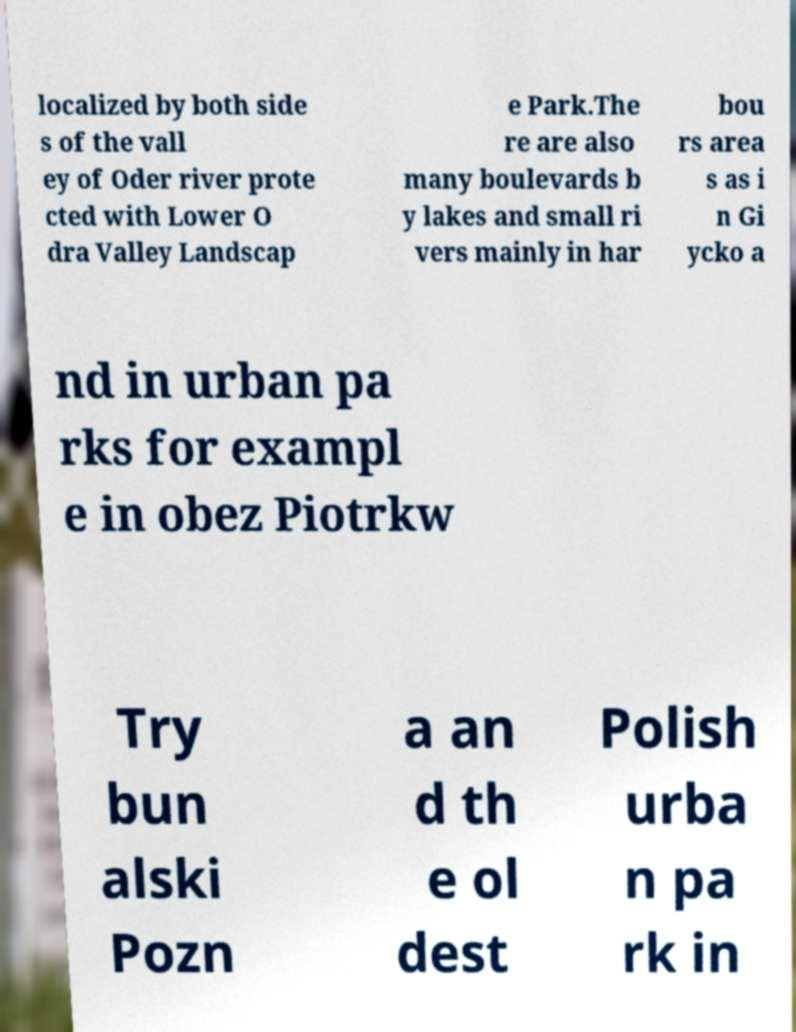What messages or text are displayed in this image? I need them in a readable, typed format. localized by both side s of the vall ey of Oder river prote cted with Lower O dra Valley Landscap e Park.The re are also many boulevards b y lakes and small ri vers mainly in har bou rs area s as i n Gi ycko a nd in urban pa rks for exampl e in obez Piotrkw Try bun alski Pozn a an d th e ol dest Polish urba n pa rk in 